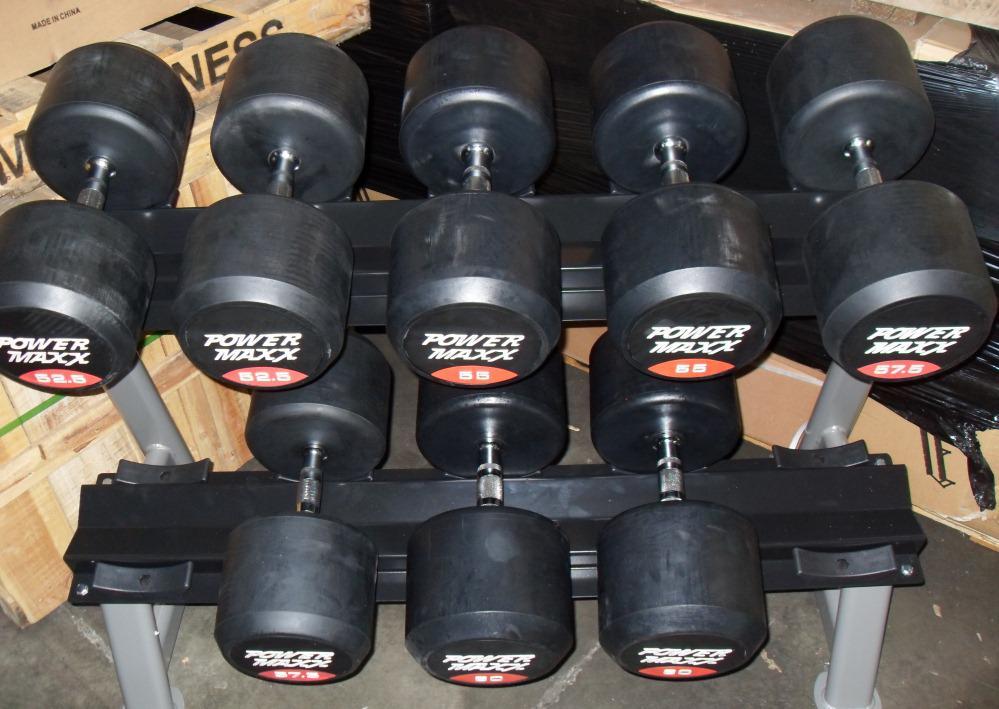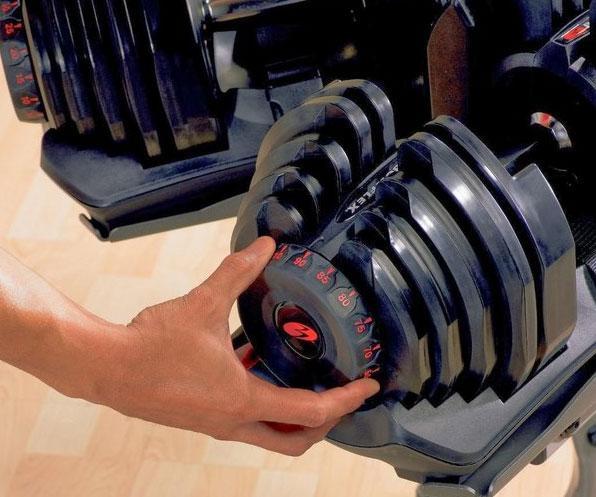The first image is the image on the left, the second image is the image on the right. Considering the images on both sides, is "In at least one image there is a single hand adjusting a red and black weight." valid? Answer yes or no. Yes. 